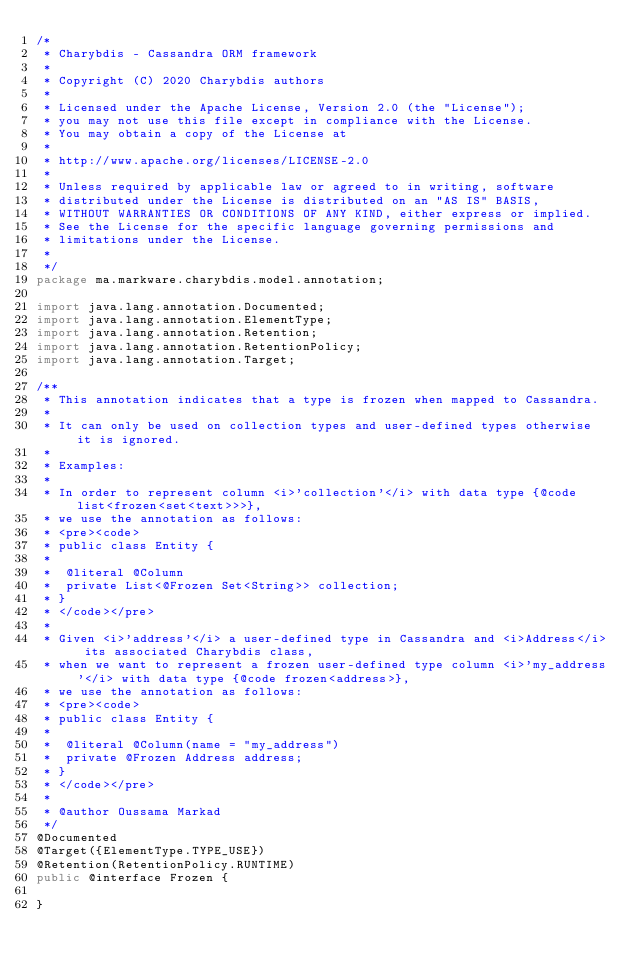Convert code to text. <code><loc_0><loc_0><loc_500><loc_500><_Java_>/*
 * Charybdis - Cassandra ORM framework
 *
 * Copyright (C) 2020 Charybdis authors
 *
 * Licensed under the Apache License, Version 2.0 (the "License");
 * you may not use this file except in compliance with the License.
 * You may obtain a copy of the License at
 *
 * http://www.apache.org/licenses/LICENSE-2.0
 *
 * Unless required by applicable law or agreed to in writing, software
 * distributed under the License is distributed on an "AS IS" BASIS,
 * WITHOUT WARRANTIES OR CONDITIONS OF ANY KIND, either express or implied.
 * See the License for the specific language governing permissions and
 * limitations under the License.
 *
 */
package ma.markware.charybdis.model.annotation;

import java.lang.annotation.Documented;
import java.lang.annotation.ElementType;
import java.lang.annotation.Retention;
import java.lang.annotation.RetentionPolicy;
import java.lang.annotation.Target;

/**
 * This annotation indicates that a type is frozen when mapped to Cassandra.
 *
 * It can only be used on collection types and user-defined types otherwise it is ignored.
 *
 * Examples:
 *
 * In order to represent column <i>'collection'</i> with data type {@code list<frozen<set<text>>>},
 * we use the annotation as follows:
 * <pre><code>
 * public class Entity {
 *
 *  @literal @Column
 *  private List<@Frozen Set<String>> collection;
 * }
 * </code></pre>
 *
 * Given <i>'address'</i> a user-defined type in Cassandra and <i>Address</i> its associated Charybdis class,
 * when we want to represent a frozen user-defined type column <i>'my_address'</i> with data type {@code frozen<address>},
 * we use the annotation as follows:
 * <pre><code>
 * public class Entity {
 *
 *  @literal @Column(name = "my_address")
 *  private @Frozen Address address;
 * }
 * </code></pre>
 *
 * @author Oussama Markad
 */
@Documented
@Target({ElementType.TYPE_USE})
@Retention(RetentionPolicy.RUNTIME)
public @interface Frozen {

}
</code> 